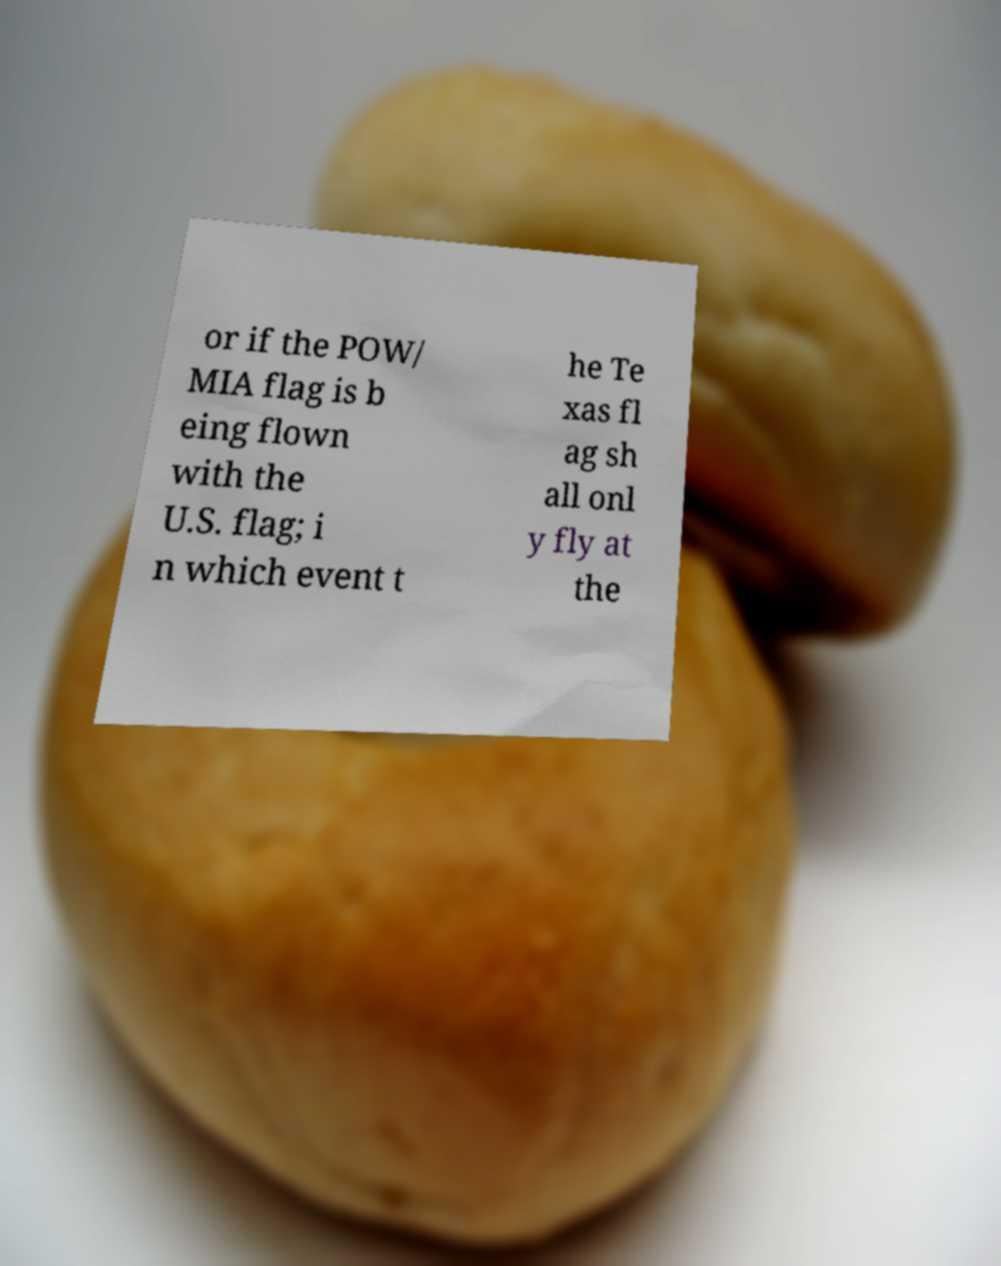For documentation purposes, I need the text within this image transcribed. Could you provide that? or if the POW/ MIA flag is b eing flown with the U.S. flag; i n which event t he Te xas fl ag sh all onl y fly at the 